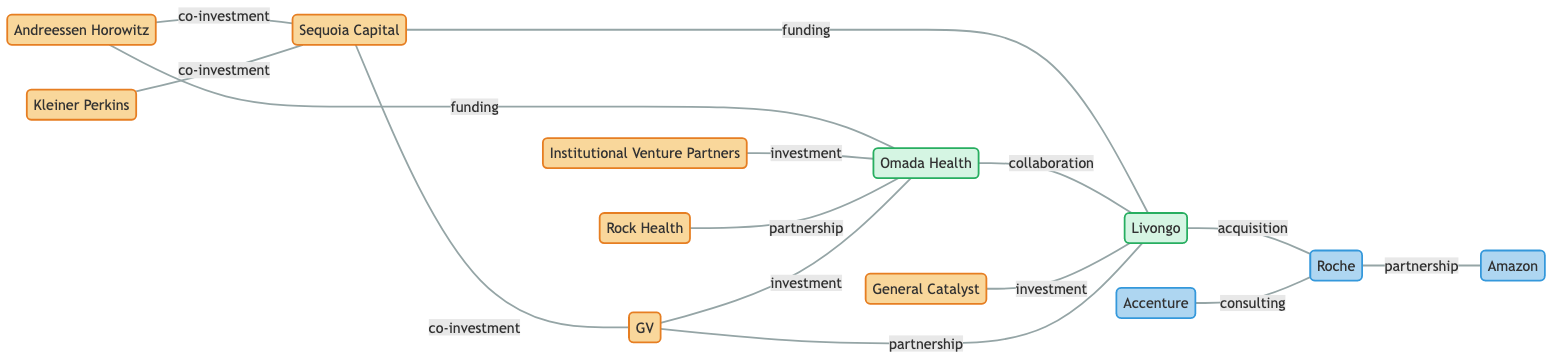What is the total number of nodes in the graph? The graph lists various nodes that represent companies and venture capital firms. Counting the entries in the "nodes" array reveals a total of 11 distinct entities.
Answer: 11 Which two nodes have a "co-investment" relationship? By examining the edges, the nodes connected with a "co-investment" label are Andreessen Horowitz and Sequoia Capital as well as Sequoia Capital and GV.
Answer: Andreessen Horowitz and Sequoia Capital How many partnerships are indicated in the graph? The edges labeled as "partnership" occur between two distinct nodes. By identifying these edges, I see there are two: Rock Health and Omada Health, and Roche and Amazon.
Answer: 2 What type of organization is "Livongo"? "Livongo" is identified in the diagram as a MedTech company, categorized under the color and style associated with MedTech firms.
Answer: MedTech Which venture capital firms have invested in "Omada Health"? The edges connected to "Omada Health" reveal that both Andreessen Horowitz and Institutional Venture Partners have invested in it.
Answer: Andreessen Horowitz and Institutional Venture Partners What is the relationship type between "Livongo" and "Roche"? The edge connecting these two nodes specifically indicates that "Livongo" is acquired by "Roche," which denotes an acquisition relationship.
Answer: acquisition How many edges are present in the graph? By counting the edges depicted in the connections between the nodes, a total of 13 edges can be identified in the diagram.
Answer: 13 Which node has the most connections? Analyzing the degrees of each node, "Omada Health" is connected to four other nodes, indicating it has the highest number of relationships represented by edges.
Answer: Omada Health What investment type is associated with "General Catalyst" and "Livongo"? The edge labeled between these two nodes identifies the relationship as "investment," indicating that General Catalyst has invested in Livongo.
Answer: investment What is the label for the edge connecting "Roche" and "Amazon"? The edge between "Roche" and "Amazon" is labeled as "partnership," which specifies the nature of their connection.
Answer: partnership 